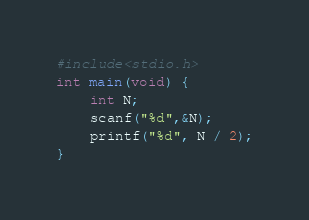<code> <loc_0><loc_0><loc_500><loc_500><_C_>#include<stdio.h>
int main(void) {
	int N;
	scanf("%d",&N);
	printf("%d", N / 2);
}</code> 